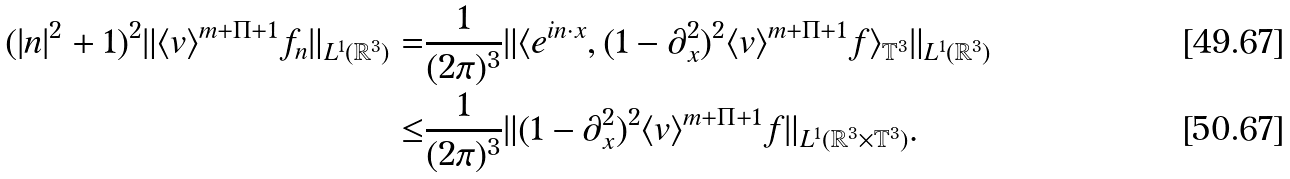Convert formula to latex. <formula><loc_0><loc_0><loc_500><loc_500>( | { n } | ^ { 2 } + 1 ) ^ { 2 } \| \langle v \rangle ^ { m + \Pi + 1 } f _ { n } \| _ { L ^ { 1 } ( \mathbb { R } ^ { 3 } ) } = & \frac { 1 } { ( 2 \pi ) ^ { 3 } } \| \langle e ^ { i n \cdot x } , ( 1 - \partial _ { x } ^ { 2 } ) ^ { 2 } \langle v \rangle ^ { m + \Pi + 1 } f \rangle _ { \mathbb { T } ^ { 3 } } \| _ { L ^ { 1 } ( \mathbb { R } ^ { 3 } ) } \\ \leq & \frac { 1 } { ( 2 \pi ) ^ { 3 } } \| ( 1 - \partial _ { x } ^ { 2 } ) ^ { 2 } \langle v \rangle ^ { m + \Pi + 1 } f \| _ { L ^ { 1 } ( \mathbb { R } ^ { 3 } \times \mathbb { T } ^ { 3 } ) } .</formula> 